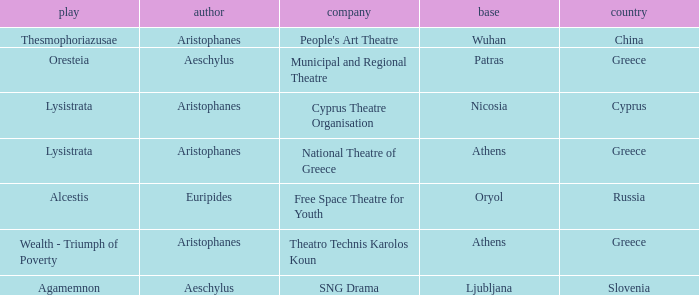What is the base when the play is thesmophoriazusae? Wuhan. Can you parse all the data within this table? {'header': ['play', 'author', 'company', 'base', 'country'], 'rows': [['Thesmophoriazusae', 'Aristophanes', "People's Art Theatre", 'Wuhan', 'China'], ['Oresteia', 'Aeschylus', 'Municipal and Regional Theatre', 'Patras', 'Greece'], ['Lysistrata', 'Aristophanes', 'Cyprus Theatre Organisation', 'Nicosia', 'Cyprus'], ['Lysistrata', 'Aristophanes', 'National Theatre of Greece', 'Athens', 'Greece'], ['Alcestis', 'Euripides', 'Free Space Theatre for Youth', 'Oryol', 'Russia'], ['Wealth - Triumph of Poverty', 'Aristophanes', 'Theatro Technis Karolos Koun', 'Athens', 'Greece'], ['Agamemnon', 'Aeschylus', 'SNG Drama', 'Ljubljana', 'Slovenia']]} 